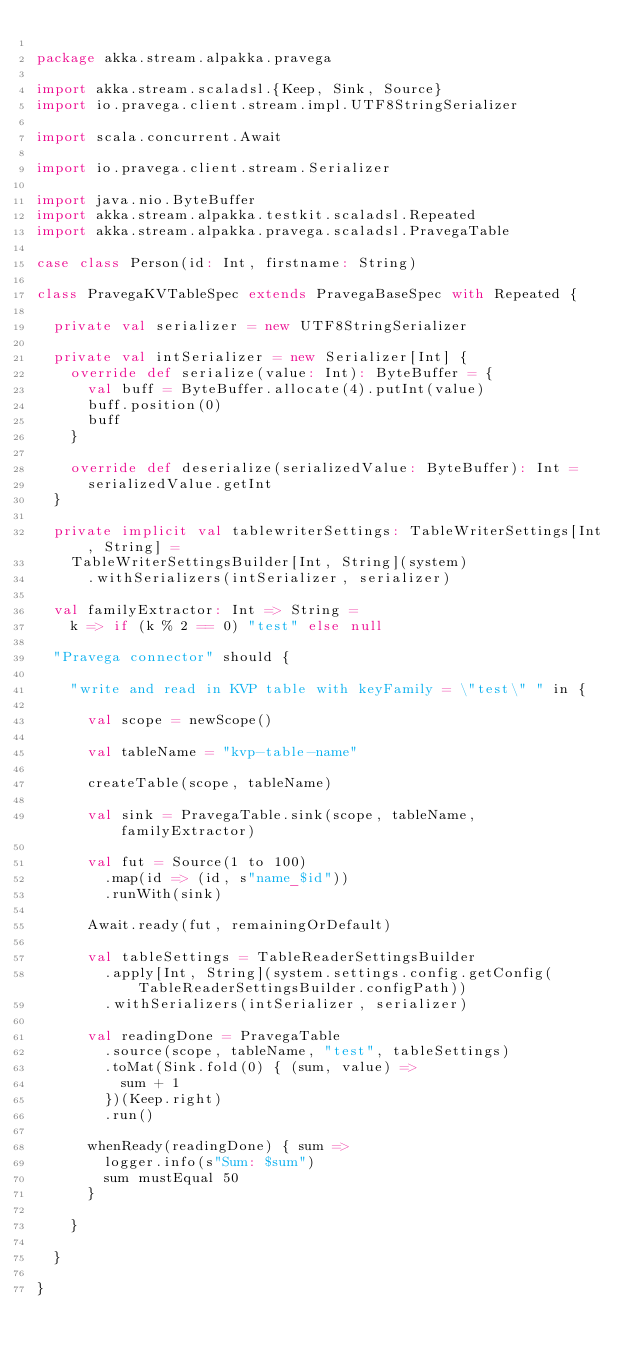Convert code to text. <code><loc_0><loc_0><loc_500><loc_500><_Scala_>
package akka.stream.alpakka.pravega

import akka.stream.scaladsl.{Keep, Sink, Source}
import io.pravega.client.stream.impl.UTF8StringSerializer

import scala.concurrent.Await

import io.pravega.client.stream.Serializer

import java.nio.ByteBuffer
import akka.stream.alpakka.testkit.scaladsl.Repeated
import akka.stream.alpakka.pravega.scaladsl.PravegaTable

case class Person(id: Int, firstname: String)

class PravegaKVTableSpec extends PravegaBaseSpec with Repeated {

  private val serializer = new UTF8StringSerializer

  private val intSerializer = new Serializer[Int] {
    override def serialize(value: Int): ByteBuffer = {
      val buff = ByteBuffer.allocate(4).putInt(value)
      buff.position(0)
      buff
    }

    override def deserialize(serializedValue: ByteBuffer): Int =
      serializedValue.getInt
  }

  private implicit val tablewriterSettings: TableWriterSettings[Int, String] =
    TableWriterSettingsBuilder[Int, String](system)
      .withSerializers(intSerializer, serializer)

  val familyExtractor: Int => String =
    k => if (k % 2 == 0) "test" else null

  "Pravega connector" should {

    "write and read in KVP table with keyFamily = \"test\" " in {

      val scope = newScope()

      val tableName = "kvp-table-name"

      createTable(scope, tableName)

      val sink = PravegaTable.sink(scope, tableName, familyExtractor)

      val fut = Source(1 to 100)
        .map(id => (id, s"name_$id"))
        .runWith(sink)

      Await.ready(fut, remainingOrDefault)

      val tableSettings = TableReaderSettingsBuilder
        .apply[Int, String](system.settings.config.getConfig(TableReaderSettingsBuilder.configPath))
        .withSerializers(intSerializer, serializer)

      val readingDone = PravegaTable
        .source(scope, tableName, "test", tableSettings)
        .toMat(Sink.fold(0) { (sum, value) =>
          sum + 1
        })(Keep.right)
        .run()

      whenReady(readingDone) { sum =>
        logger.info(s"Sum: $sum")
        sum mustEqual 50
      }

    }

  }

}
</code> 